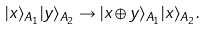<formula> <loc_0><loc_0><loc_500><loc_500>| x \rangle _ { A _ { 1 } } | y \rangle _ { A _ { 2 } } \rightarrow | x \oplus y \rangle _ { A _ { 1 } } | x \rangle _ { A _ { 2 } } .</formula> 